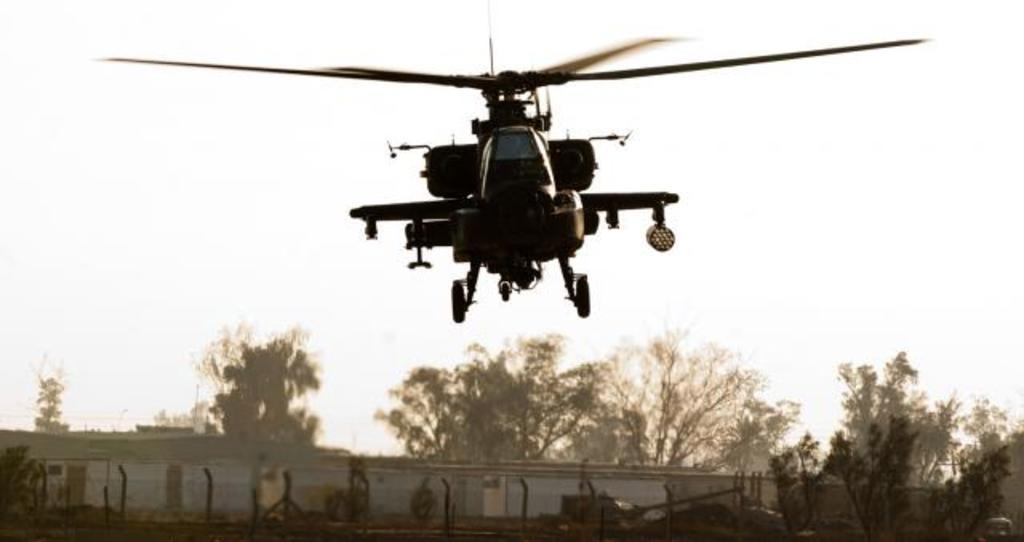What is the main subject of the image? The main subject of the image is a helicopter flying. What can be seen in the background of the image? In the background of the image, there are trees, fencing, and buildings. How would you describe the sky in the image? The sky is clear in the image. What type of order is the ladybug following in the image? There is no ladybug present in the image, so it is not possible to determine any order it might be following. 